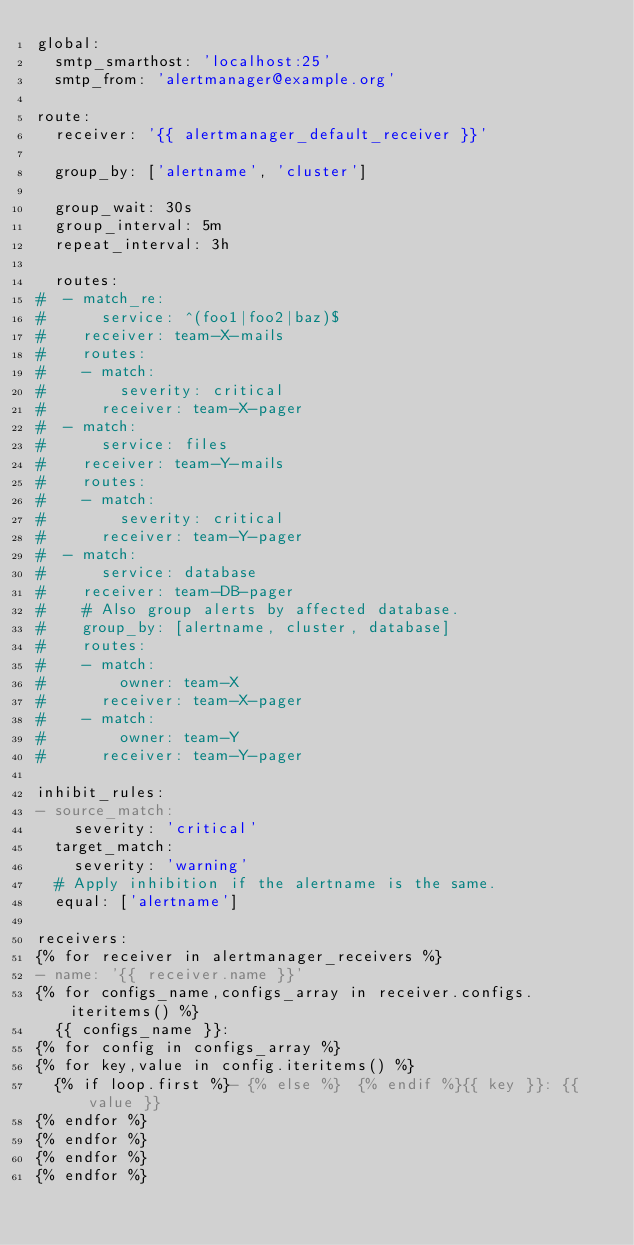Convert code to text. <code><loc_0><loc_0><loc_500><loc_500><_YAML_>global:
  smtp_smarthost: 'localhost:25'
  smtp_from: 'alertmanager@example.org'

route:
  receiver: '{{ alertmanager_default_receiver }}'

  group_by: ['alertname', 'cluster']

  group_wait: 30s
  group_interval: 5m
  repeat_interval: 3h

  routes:
#  - match_re:
#      service: ^(foo1|foo2|baz)$
#    receiver: team-X-mails
#    routes:
#    - match:
#        severity: critical
#      receiver: team-X-pager
#  - match:
#      service: files
#    receiver: team-Y-mails
#    routes:
#    - match:
#        severity: critical
#      receiver: team-Y-pager
#  - match:
#      service: database
#    receiver: team-DB-pager
#    # Also group alerts by affected database.
#    group_by: [alertname, cluster, database]
#    routes:
#    - match:
#        owner: team-X
#      receiver: team-X-pager
#    - match:
#        owner: team-Y
#      receiver: team-Y-pager

inhibit_rules:
- source_match:
    severity: 'critical'
  target_match:
    severity: 'warning'
  # Apply inhibition if the alertname is the same.
  equal: ['alertname']

receivers:
{% for receiver in alertmanager_receivers %}
- name: '{{ receiver.name }}'
{% for configs_name,configs_array in receiver.configs.iteritems() %}
  {{ configs_name }}:
{% for config in configs_array %}
{% for key,value in config.iteritems() %}
  {% if loop.first %}- {% else %}  {% endif %}{{ key }}: {{ value }}
{% endfor %}
{% endfor %}
{% endfor %}
{% endfor %}
</code> 